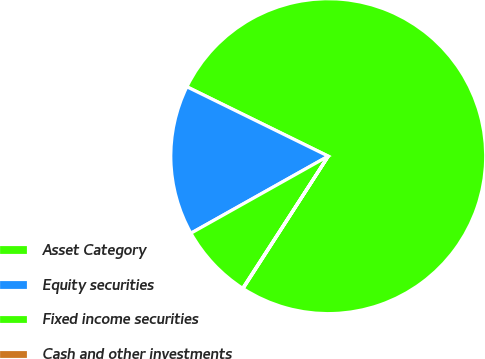Convert chart. <chart><loc_0><loc_0><loc_500><loc_500><pie_chart><fcel>Asset Category<fcel>Equity securities<fcel>Fixed income securities<fcel>Cash and other investments<nl><fcel>76.84%<fcel>15.4%<fcel>7.72%<fcel>0.04%<nl></chart> 